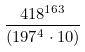Convert formula to latex. <formula><loc_0><loc_0><loc_500><loc_500>\frac { 4 1 8 ^ { 1 6 3 } } { ( 1 9 7 ^ { 4 } \cdot 1 0 ) }</formula> 